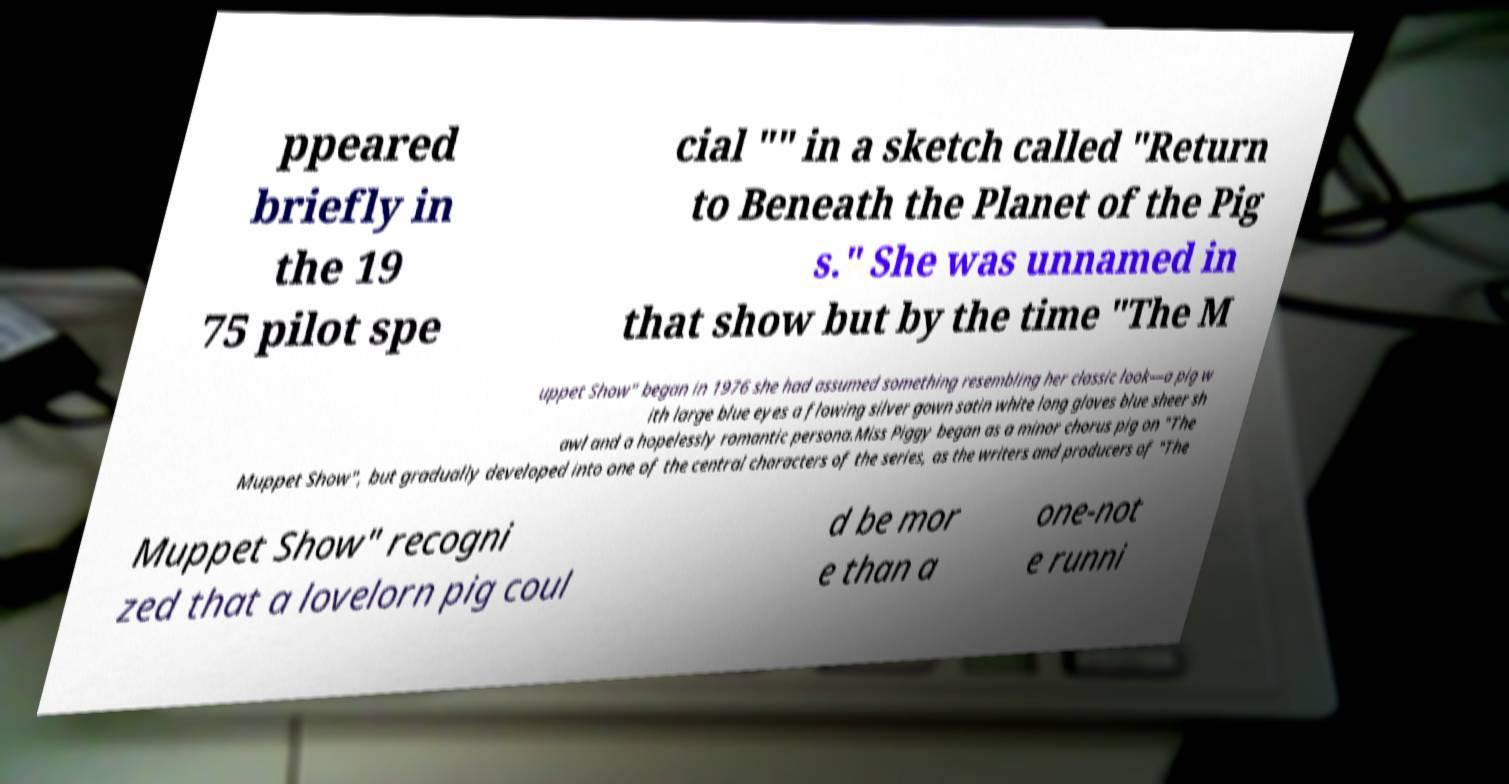I need the written content from this picture converted into text. Can you do that? ppeared briefly in the 19 75 pilot spe cial "" in a sketch called "Return to Beneath the Planet of the Pig s." She was unnamed in that show but by the time "The M uppet Show" began in 1976 she had assumed something resembling her classic look—a pig w ith large blue eyes a flowing silver gown satin white long gloves blue sheer sh awl and a hopelessly romantic persona.Miss Piggy began as a minor chorus pig on "The Muppet Show", but gradually developed into one of the central characters of the series, as the writers and producers of "The Muppet Show" recogni zed that a lovelorn pig coul d be mor e than a one-not e runni 